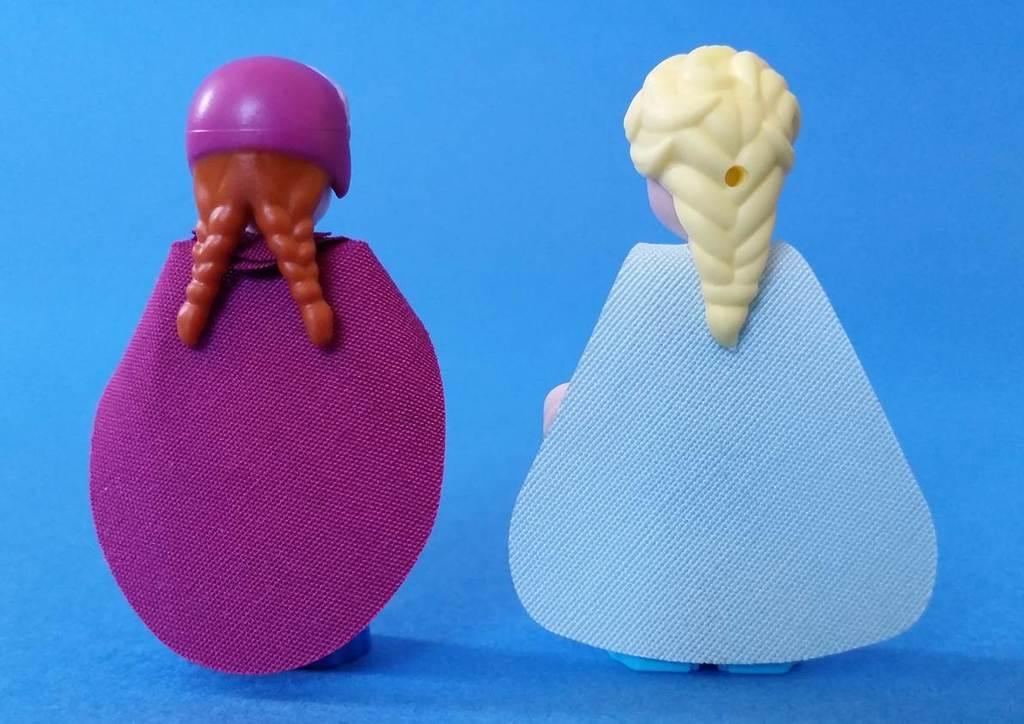What type of toys are present in the image? There are two small girl toys in the image. What material are the toys made of? The toys are made of plastic material. What colors can be seen on the toys' fabric? The toys have blue and purple fabric. What type of answer can be seen in the image? There is no answer present in the image; it features two small girl toys made of plastic with blue and purple fabric. 